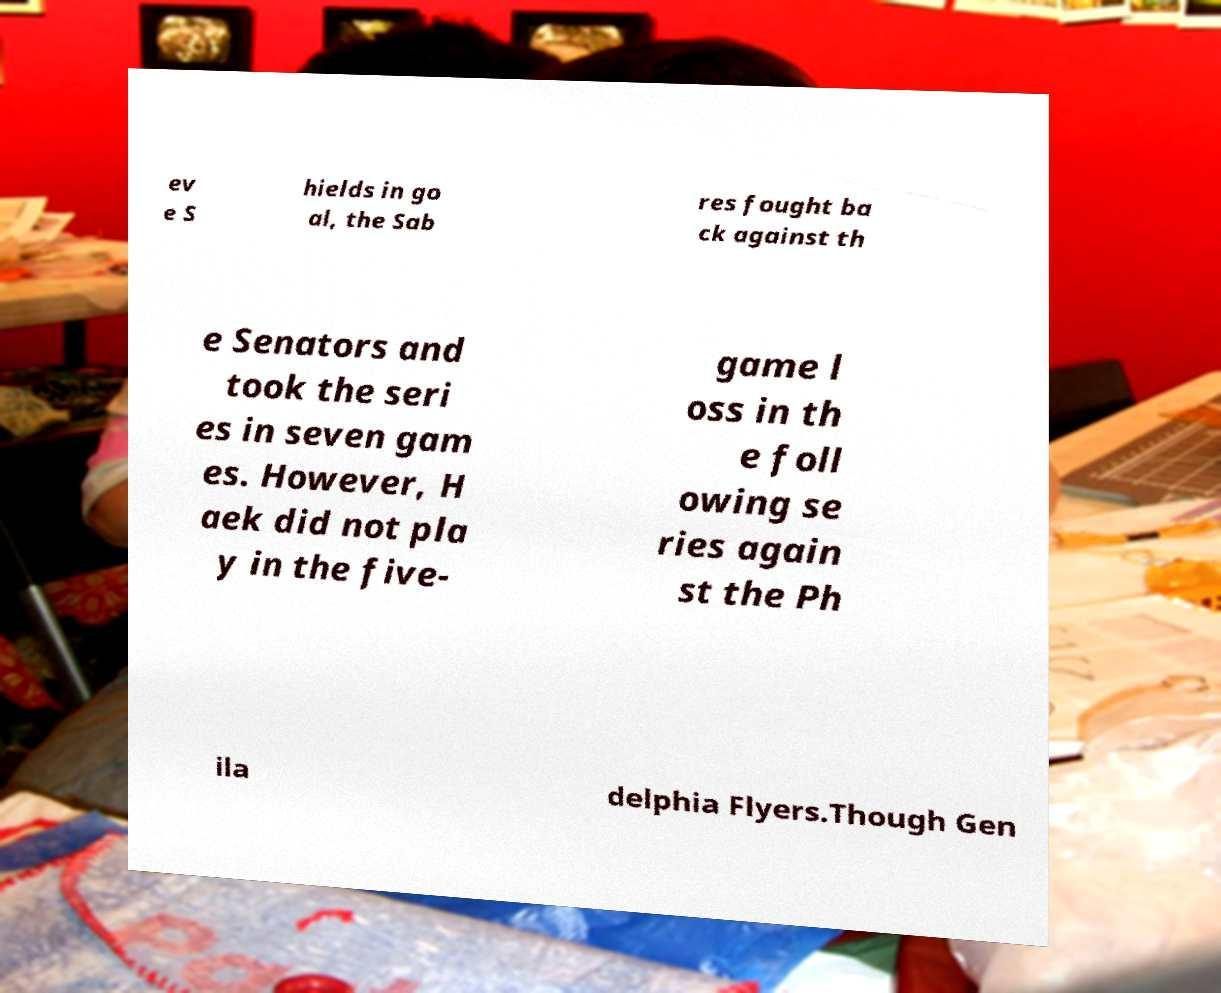Can you accurately transcribe the text from the provided image for me? ev e S hields in go al, the Sab res fought ba ck against th e Senators and took the seri es in seven gam es. However, H aek did not pla y in the five- game l oss in th e foll owing se ries again st the Ph ila delphia Flyers.Though Gen 